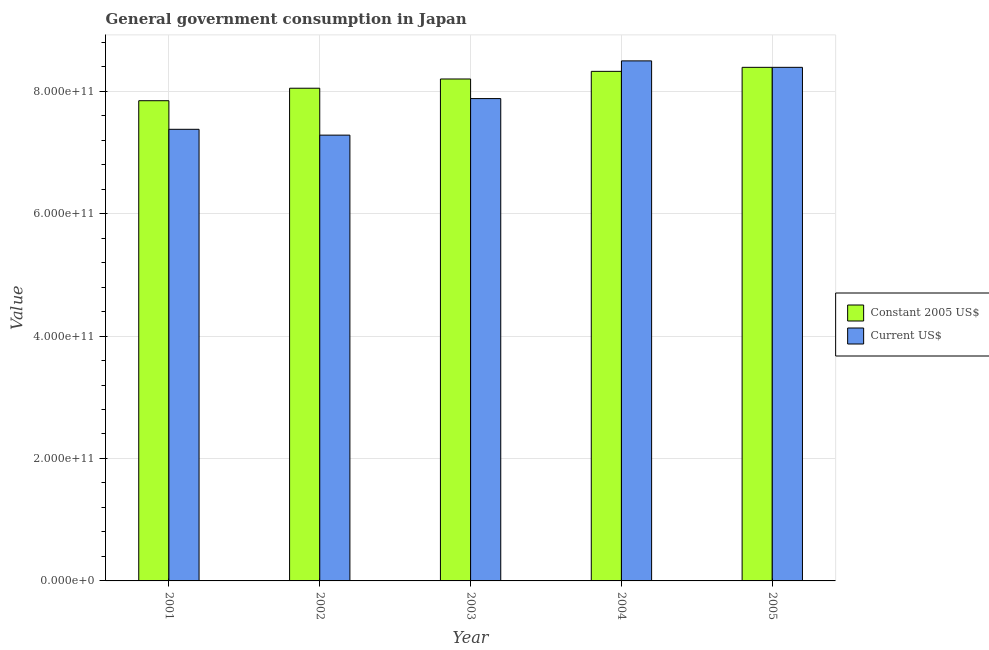How many groups of bars are there?
Offer a terse response. 5. Are the number of bars per tick equal to the number of legend labels?
Offer a terse response. Yes. How many bars are there on the 3rd tick from the left?
Provide a short and direct response. 2. How many bars are there on the 2nd tick from the right?
Your response must be concise. 2. In how many cases, is the number of bars for a given year not equal to the number of legend labels?
Offer a very short reply. 0. What is the value consumed in current us$ in 2002?
Ensure brevity in your answer.  7.28e+11. Across all years, what is the maximum value consumed in constant 2005 us$?
Make the answer very short. 8.39e+11. Across all years, what is the minimum value consumed in constant 2005 us$?
Provide a succinct answer. 7.84e+11. In which year was the value consumed in constant 2005 us$ maximum?
Offer a very short reply. 2005. What is the total value consumed in constant 2005 us$ in the graph?
Give a very brief answer. 4.08e+12. What is the difference between the value consumed in constant 2005 us$ in 2004 and that in 2005?
Your answer should be very brief. -6.57e+09. What is the difference between the value consumed in current us$ in 2004 and the value consumed in constant 2005 us$ in 2002?
Give a very brief answer. 1.21e+11. What is the average value consumed in current us$ per year?
Offer a terse response. 7.88e+11. In how many years, is the value consumed in current us$ greater than 120000000000?
Your response must be concise. 5. What is the ratio of the value consumed in constant 2005 us$ in 2002 to that in 2003?
Make the answer very short. 0.98. Is the value consumed in constant 2005 us$ in 2002 less than that in 2004?
Make the answer very short. Yes. What is the difference between the highest and the second highest value consumed in constant 2005 us$?
Keep it short and to the point. 6.57e+09. What is the difference between the highest and the lowest value consumed in constant 2005 us$?
Your response must be concise. 5.45e+1. Is the sum of the value consumed in constant 2005 us$ in 2002 and 2003 greater than the maximum value consumed in current us$ across all years?
Offer a terse response. Yes. What does the 2nd bar from the left in 2004 represents?
Ensure brevity in your answer.  Current US$. What does the 2nd bar from the right in 2003 represents?
Offer a terse response. Constant 2005 US$. How many years are there in the graph?
Your answer should be compact. 5. What is the difference between two consecutive major ticks on the Y-axis?
Ensure brevity in your answer.  2.00e+11. Does the graph contain any zero values?
Your answer should be very brief. No. Does the graph contain grids?
Give a very brief answer. Yes. Where does the legend appear in the graph?
Offer a very short reply. Center right. How many legend labels are there?
Provide a short and direct response. 2. What is the title of the graph?
Ensure brevity in your answer.  General government consumption in Japan. Does "By country of origin" appear as one of the legend labels in the graph?
Your answer should be compact. No. What is the label or title of the X-axis?
Give a very brief answer. Year. What is the label or title of the Y-axis?
Offer a very short reply. Value. What is the Value in Constant 2005 US$ in 2001?
Provide a short and direct response. 7.84e+11. What is the Value of Current US$ in 2001?
Give a very brief answer. 7.38e+11. What is the Value in Constant 2005 US$ in 2002?
Your answer should be very brief. 8.05e+11. What is the Value of Current US$ in 2002?
Provide a succinct answer. 7.28e+11. What is the Value in Constant 2005 US$ in 2003?
Give a very brief answer. 8.20e+11. What is the Value of Current US$ in 2003?
Provide a succinct answer. 7.88e+11. What is the Value of Constant 2005 US$ in 2004?
Offer a terse response. 8.32e+11. What is the Value of Current US$ in 2004?
Make the answer very short. 8.49e+11. What is the Value of Constant 2005 US$ in 2005?
Offer a terse response. 8.39e+11. What is the Value of Current US$ in 2005?
Your answer should be compact. 8.39e+11. Across all years, what is the maximum Value in Constant 2005 US$?
Ensure brevity in your answer.  8.39e+11. Across all years, what is the maximum Value of Current US$?
Keep it short and to the point. 8.49e+11. Across all years, what is the minimum Value of Constant 2005 US$?
Offer a very short reply. 7.84e+11. Across all years, what is the minimum Value of Current US$?
Your answer should be compact. 7.28e+11. What is the total Value of Constant 2005 US$ in the graph?
Your answer should be compact. 4.08e+12. What is the total Value of Current US$ in the graph?
Your answer should be very brief. 3.94e+12. What is the difference between the Value of Constant 2005 US$ in 2001 and that in 2002?
Provide a short and direct response. -2.04e+1. What is the difference between the Value in Current US$ in 2001 and that in 2002?
Your answer should be very brief. 9.53e+09. What is the difference between the Value in Constant 2005 US$ in 2001 and that in 2003?
Your response must be concise. -3.55e+1. What is the difference between the Value in Current US$ in 2001 and that in 2003?
Your answer should be compact. -5.02e+1. What is the difference between the Value of Constant 2005 US$ in 2001 and that in 2004?
Offer a terse response. -4.80e+1. What is the difference between the Value in Current US$ in 2001 and that in 2004?
Provide a short and direct response. -1.12e+11. What is the difference between the Value in Constant 2005 US$ in 2001 and that in 2005?
Provide a short and direct response. -5.45e+1. What is the difference between the Value in Current US$ in 2001 and that in 2005?
Keep it short and to the point. -1.01e+11. What is the difference between the Value in Constant 2005 US$ in 2002 and that in 2003?
Provide a short and direct response. -1.51e+1. What is the difference between the Value of Current US$ in 2002 and that in 2003?
Provide a short and direct response. -5.97e+1. What is the difference between the Value in Constant 2005 US$ in 2002 and that in 2004?
Provide a short and direct response. -2.76e+1. What is the difference between the Value of Current US$ in 2002 and that in 2004?
Your response must be concise. -1.21e+11. What is the difference between the Value in Constant 2005 US$ in 2002 and that in 2005?
Provide a succinct answer. -3.41e+1. What is the difference between the Value of Current US$ in 2002 and that in 2005?
Your answer should be very brief. -1.11e+11. What is the difference between the Value of Constant 2005 US$ in 2003 and that in 2004?
Your answer should be compact. -1.25e+1. What is the difference between the Value in Current US$ in 2003 and that in 2004?
Your answer should be very brief. -6.16e+1. What is the difference between the Value in Constant 2005 US$ in 2003 and that in 2005?
Provide a succinct answer. -1.90e+1. What is the difference between the Value in Current US$ in 2003 and that in 2005?
Provide a succinct answer. -5.11e+1. What is the difference between the Value of Constant 2005 US$ in 2004 and that in 2005?
Give a very brief answer. -6.57e+09. What is the difference between the Value in Current US$ in 2004 and that in 2005?
Your answer should be very brief. 1.05e+1. What is the difference between the Value in Constant 2005 US$ in 2001 and the Value in Current US$ in 2002?
Offer a very short reply. 5.62e+1. What is the difference between the Value in Constant 2005 US$ in 2001 and the Value in Current US$ in 2003?
Your answer should be very brief. -3.48e+09. What is the difference between the Value in Constant 2005 US$ in 2001 and the Value in Current US$ in 2004?
Give a very brief answer. -6.51e+1. What is the difference between the Value in Constant 2005 US$ in 2001 and the Value in Current US$ in 2005?
Provide a succinct answer. -5.45e+1. What is the difference between the Value in Constant 2005 US$ in 2002 and the Value in Current US$ in 2003?
Keep it short and to the point. 1.69e+1. What is the difference between the Value of Constant 2005 US$ in 2002 and the Value of Current US$ in 2004?
Give a very brief answer. -4.47e+1. What is the difference between the Value in Constant 2005 US$ in 2002 and the Value in Current US$ in 2005?
Keep it short and to the point. -3.41e+1. What is the difference between the Value of Constant 2005 US$ in 2003 and the Value of Current US$ in 2004?
Provide a succinct answer. -2.96e+1. What is the difference between the Value in Constant 2005 US$ in 2003 and the Value in Current US$ in 2005?
Provide a short and direct response. -1.90e+1. What is the difference between the Value of Constant 2005 US$ in 2004 and the Value of Current US$ in 2005?
Ensure brevity in your answer.  -6.57e+09. What is the average Value in Constant 2005 US$ per year?
Give a very brief answer. 8.16e+11. What is the average Value of Current US$ per year?
Keep it short and to the point. 7.88e+11. In the year 2001, what is the difference between the Value in Constant 2005 US$ and Value in Current US$?
Offer a very short reply. 4.67e+1. In the year 2002, what is the difference between the Value of Constant 2005 US$ and Value of Current US$?
Your answer should be compact. 7.66e+1. In the year 2003, what is the difference between the Value in Constant 2005 US$ and Value in Current US$?
Your answer should be very brief. 3.20e+1. In the year 2004, what is the difference between the Value in Constant 2005 US$ and Value in Current US$?
Offer a terse response. -1.71e+1. In the year 2005, what is the difference between the Value of Constant 2005 US$ and Value of Current US$?
Provide a short and direct response. 0. What is the ratio of the Value of Constant 2005 US$ in 2001 to that in 2002?
Provide a short and direct response. 0.97. What is the ratio of the Value in Current US$ in 2001 to that in 2002?
Give a very brief answer. 1.01. What is the ratio of the Value in Constant 2005 US$ in 2001 to that in 2003?
Give a very brief answer. 0.96. What is the ratio of the Value of Current US$ in 2001 to that in 2003?
Make the answer very short. 0.94. What is the ratio of the Value in Constant 2005 US$ in 2001 to that in 2004?
Make the answer very short. 0.94. What is the ratio of the Value in Current US$ in 2001 to that in 2004?
Ensure brevity in your answer.  0.87. What is the ratio of the Value of Constant 2005 US$ in 2001 to that in 2005?
Your answer should be compact. 0.94. What is the ratio of the Value of Current US$ in 2001 to that in 2005?
Your response must be concise. 0.88. What is the ratio of the Value of Constant 2005 US$ in 2002 to that in 2003?
Your answer should be very brief. 0.98. What is the ratio of the Value of Current US$ in 2002 to that in 2003?
Keep it short and to the point. 0.92. What is the ratio of the Value of Constant 2005 US$ in 2002 to that in 2004?
Offer a terse response. 0.97. What is the ratio of the Value of Current US$ in 2002 to that in 2004?
Offer a very short reply. 0.86. What is the ratio of the Value of Constant 2005 US$ in 2002 to that in 2005?
Provide a short and direct response. 0.96. What is the ratio of the Value in Current US$ in 2002 to that in 2005?
Ensure brevity in your answer.  0.87. What is the ratio of the Value of Current US$ in 2003 to that in 2004?
Make the answer very short. 0.93. What is the ratio of the Value of Constant 2005 US$ in 2003 to that in 2005?
Provide a short and direct response. 0.98. What is the ratio of the Value of Current US$ in 2003 to that in 2005?
Provide a succinct answer. 0.94. What is the ratio of the Value in Current US$ in 2004 to that in 2005?
Give a very brief answer. 1.01. What is the difference between the highest and the second highest Value in Constant 2005 US$?
Provide a succinct answer. 6.57e+09. What is the difference between the highest and the second highest Value of Current US$?
Your response must be concise. 1.05e+1. What is the difference between the highest and the lowest Value in Constant 2005 US$?
Keep it short and to the point. 5.45e+1. What is the difference between the highest and the lowest Value in Current US$?
Give a very brief answer. 1.21e+11. 